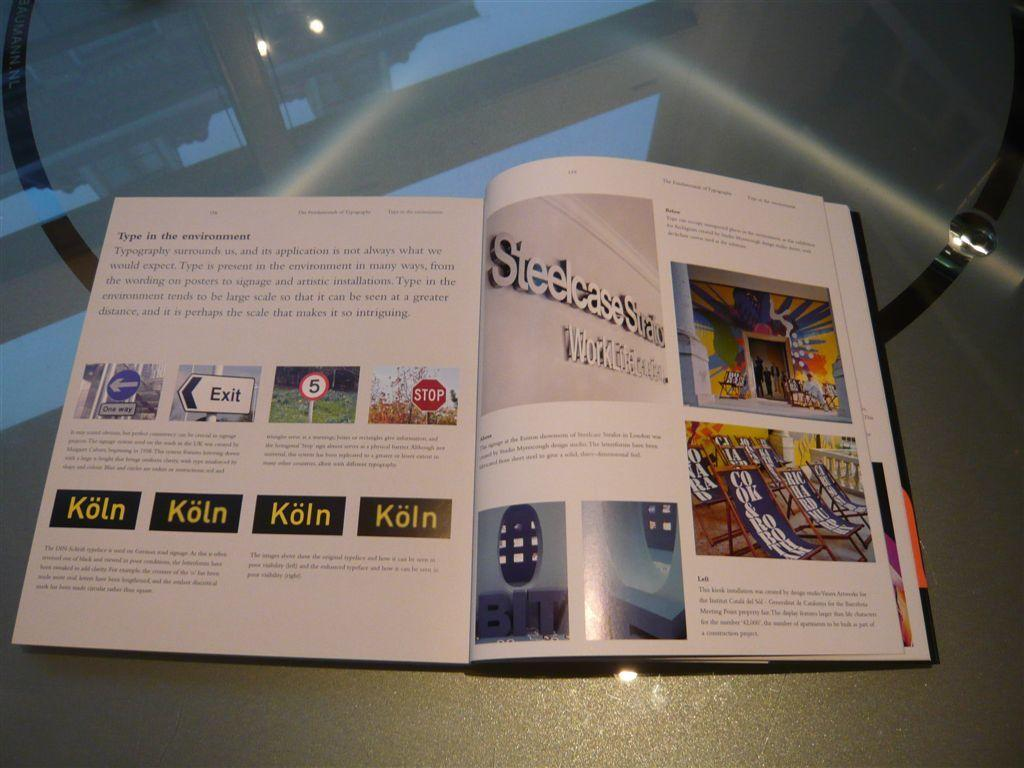Provide a one-sentence caption for the provided image. An open book which deals with the subject of typography. 